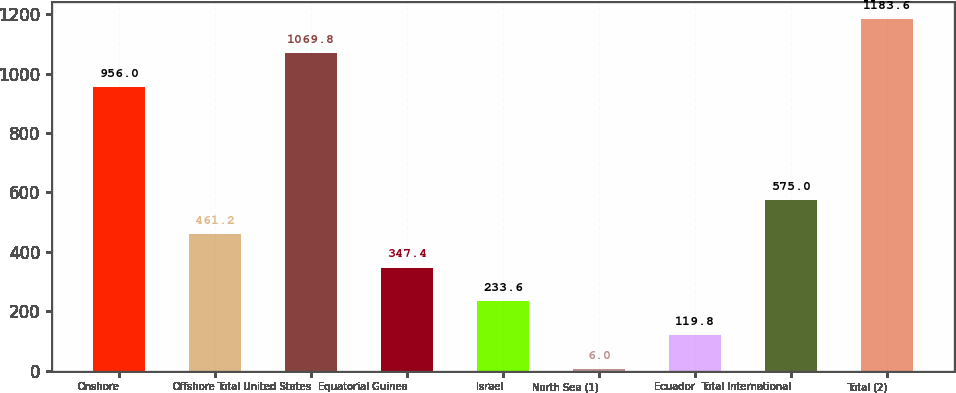Convert chart. <chart><loc_0><loc_0><loc_500><loc_500><bar_chart><fcel>Onshore<fcel>Offshore<fcel>Total United States<fcel>Equatorial Guinea<fcel>Israel<fcel>North Sea (1)<fcel>Ecuador<fcel>Total International<fcel>Total (2)<nl><fcel>956<fcel>461.2<fcel>1069.8<fcel>347.4<fcel>233.6<fcel>6<fcel>119.8<fcel>575<fcel>1183.6<nl></chart> 